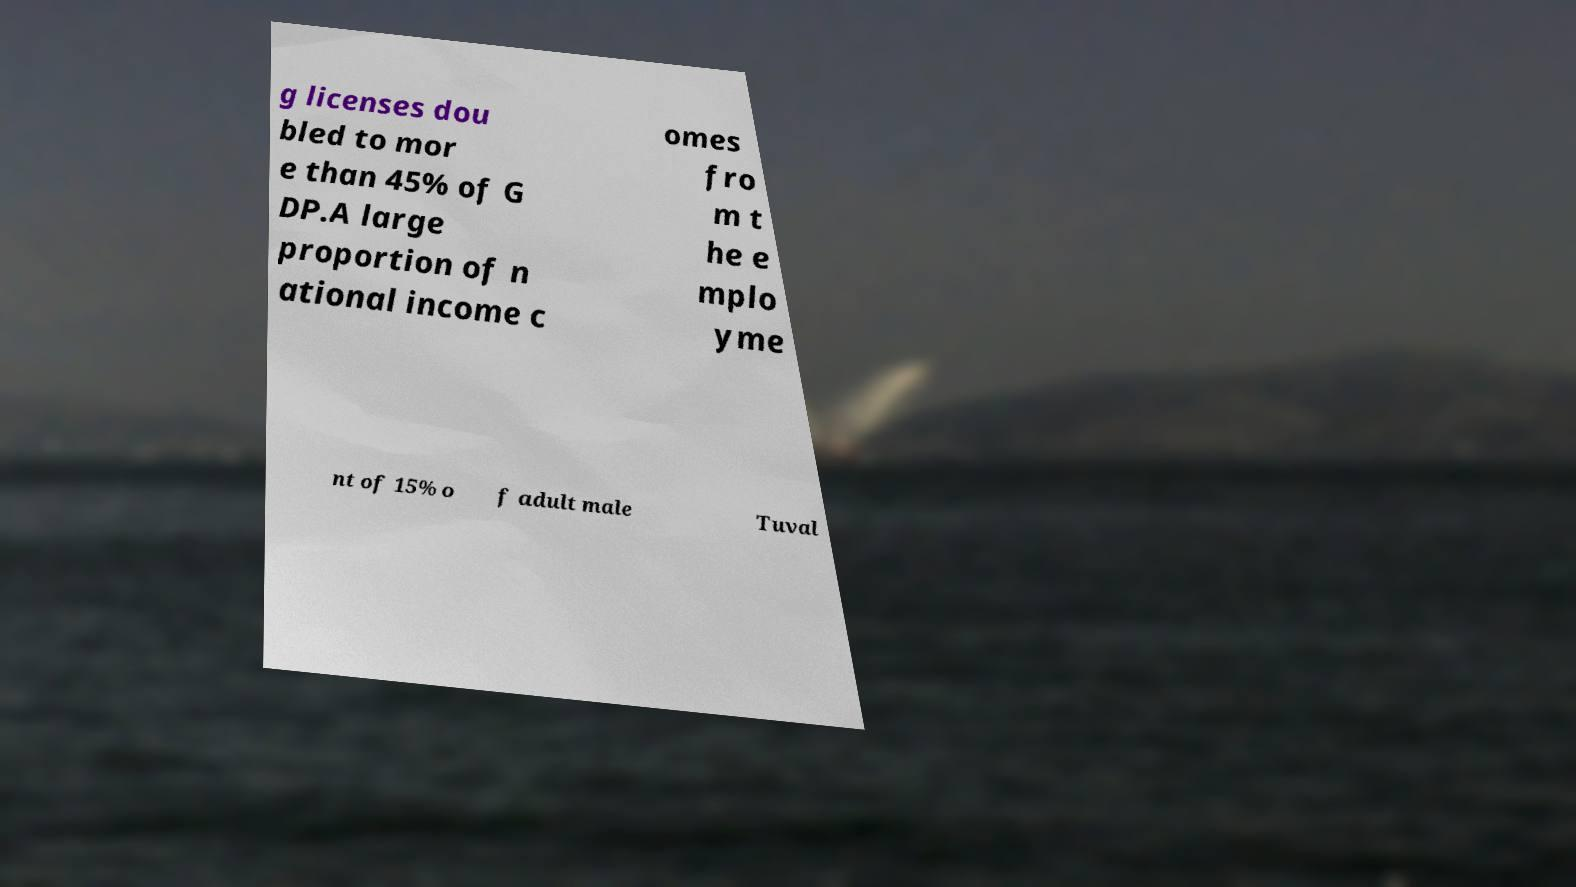Could you assist in decoding the text presented in this image and type it out clearly? g licenses dou bled to mor e than 45% of G DP.A large proportion of n ational income c omes fro m t he e mplo yme nt of 15% o f adult male Tuval 